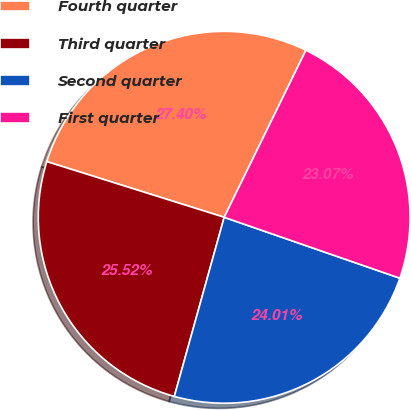Convert chart. <chart><loc_0><loc_0><loc_500><loc_500><pie_chart><fcel>Fourth quarter<fcel>Third quarter<fcel>Second quarter<fcel>First quarter<nl><fcel>27.4%<fcel>25.52%<fcel>24.01%<fcel>23.07%<nl></chart> 